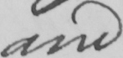What text is written in this handwritten line? and 